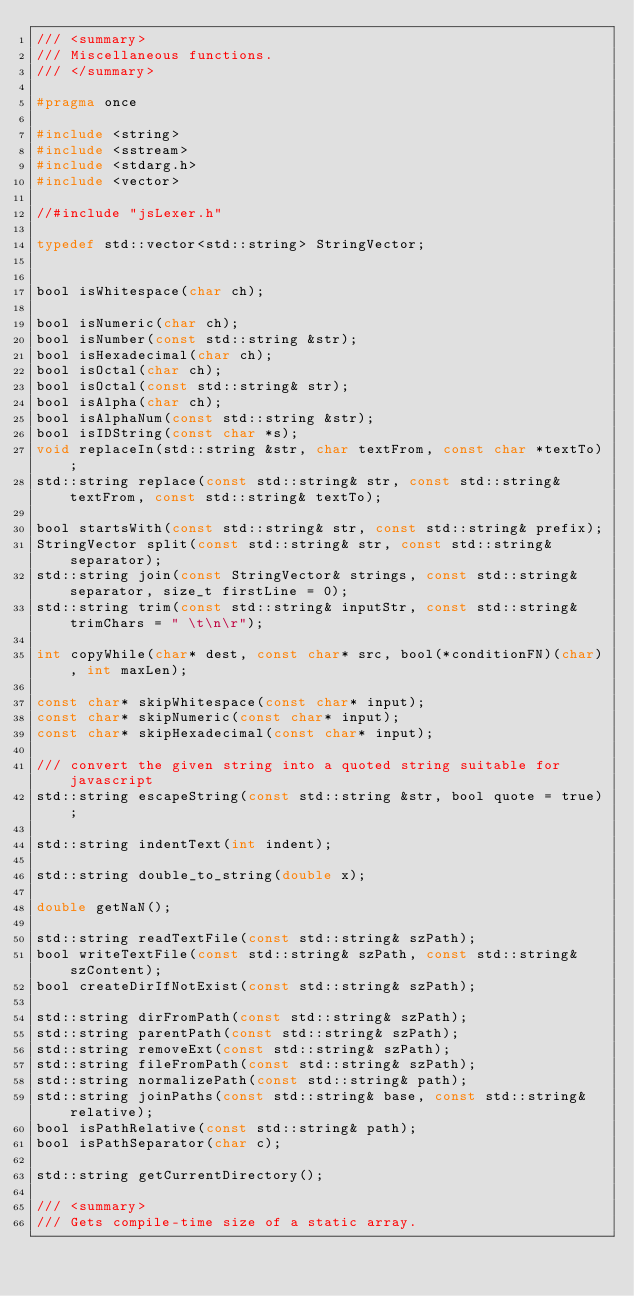Convert code to text. <code><loc_0><loc_0><loc_500><loc_500><_C_>/// <summary>
/// Miscellaneous functions. 
/// </summary>

#pragma once

#include <string>
#include <sstream>
#include <stdarg.h>
#include <vector>

//#include "jsLexer.h"

typedef std::vector<std::string> StringVector;


bool isWhitespace(char ch);

bool isNumeric(char ch);
bool isNumber(const std::string &str);
bool isHexadecimal(char ch);
bool isOctal(char ch);
bool isOctal(const std::string& str);
bool isAlpha(char ch);
bool isAlphaNum(const std::string &str);
bool isIDString(const char *s);
void replaceIn(std::string &str, char textFrom, const char *textTo);
std::string replace(const std::string& str, const std::string& textFrom, const std::string& textTo);

bool startsWith(const std::string& str, const std::string& prefix);
StringVector split(const std::string& str, const std::string& separator);
std::string join(const StringVector& strings, const std::string& separator, size_t firstLine = 0);
std::string trim(const std::string& inputStr, const std::string& trimChars = " \t\n\r");

int copyWhile(char* dest, const char* src, bool(*conditionFN)(char), int maxLen);

const char* skipWhitespace(const char* input);
const char* skipNumeric(const char* input);
const char* skipHexadecimal(const char* input);

/// convert the given string into a quoted string suitable for javascript
std::string escapeString(const std::string &str, bool quote = true);

std::string indentText(int indent);

std::string double_to_string(double x);

double getNaN();

std::string readTextFile(const std::string& szPath);
bool writeTextFile(const std::string& szPath, const std::string& szContent);
bool createDirIfNotExist(const std::string& szPath);

std::string dirFromPath(const std::string& szPath);
std::string parentPath(const std::string& szPath);
std::string removeExt(const std::string& szPath);
std::string fileFromPath(const std::string& szPath);
std::string normalizePath(const std::string& path);
std::string joinPaths(const std::string& base, const std::string& relative);
bool isPathRelative(const std::string& path);
bool isPathSeparator(char c);

std::string getCurrentDirectory();

/// <summary>
/// Gets compile-time size of a static array.</code> 